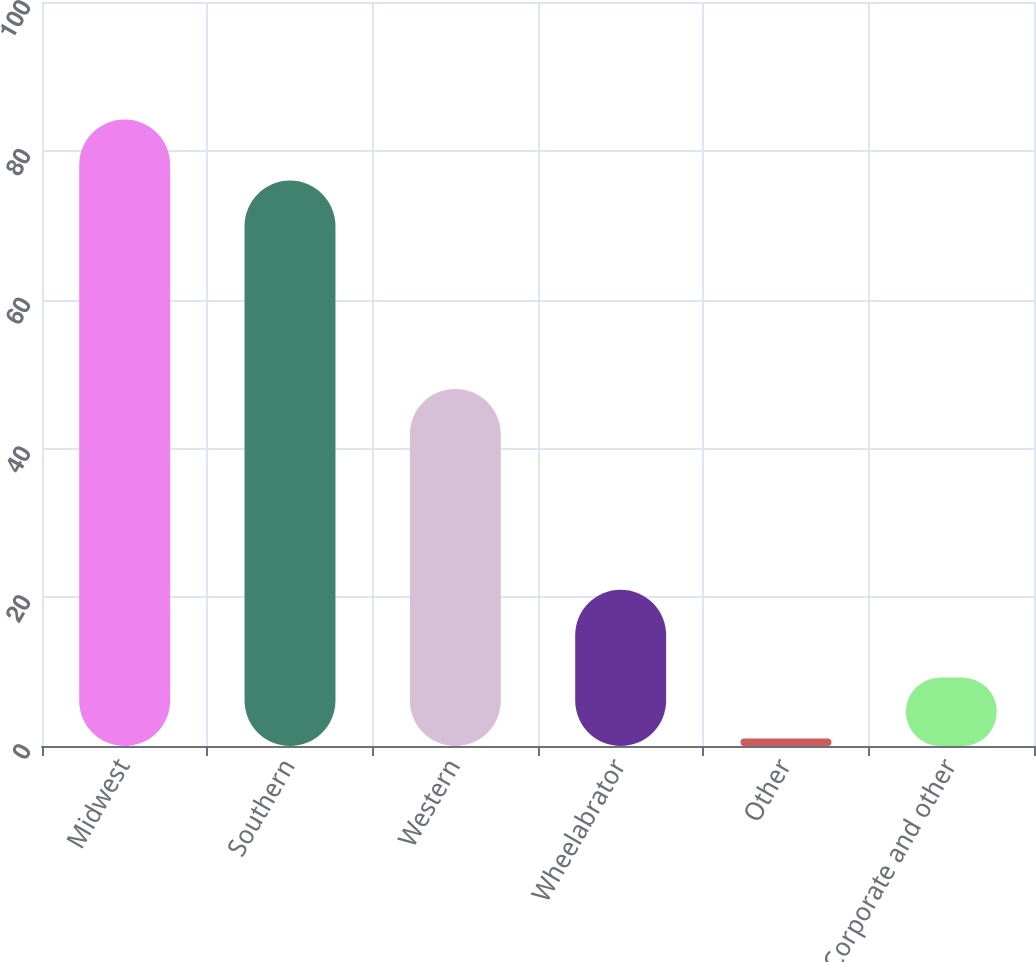<chart> <loc_0><loc_0><loc_500><loc_500><bar_chart><fcel>Midwest<fcel>Southern<fcel>Western<fcel>Wheelabrator<fcel>Other<fcel>Corporate and other<nl><fcel>84.2<fcel>76<fcel>48<fcel>21<fcel>1<fcel>9.2<nl></chart> 